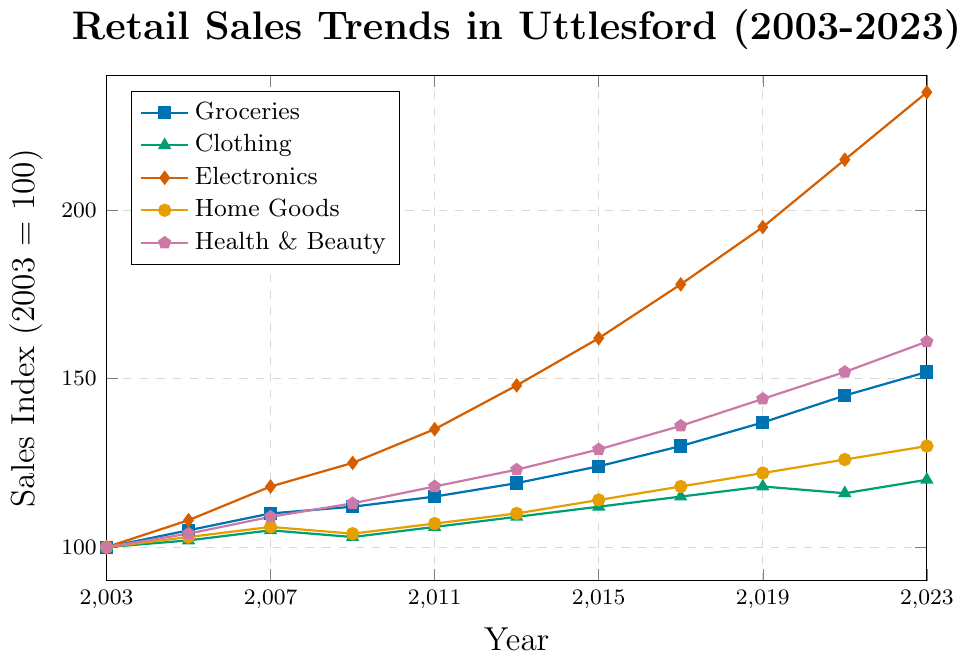What is the trend for Electronics sales from 2003 to 2023? By observing the line representing Electronics, which is marked by diamonds and colored red, it starts at 100 in 2003 and consistently increases, reaching 235 in 2023.
Answer: Increasing Which product category showed the highest sales increase over the 20 years? By comparing the ending values of each product category in 2023, Electronics showed the highest increase from 100 in 2003 to 235 in 2023.
Answer: Electronics How did Clothing sales change from 2019 to 2021? By observing the green line with triangles for Clothing, it slightly decreased from 118 in 2019 to 116 in 2021.
Answer: Decreased What was the average sales index of Groceries in the years 2011, 2015, and 2019? The value for Groceries in 2011 is 115, in 2015 is 124, and in 2019 is 137. Adding these values results in 115 + 124 + 137 = 376, and the average is 376 / 3 = 125.33.
Answer: 125.33 Compare Home Goods and Health & Beauty sales in 2023. Which was higher and by how much? The value for Home Goods in 2023 is 130, and for Health & Beauty, it is 161. The difference is 161 - 130 = 31.
Answer: Health & Beauty by 31 Which product category had the most stable sales trend over the 20 years, with the least fluctuations? By examining the slopes of the trends, Clothing (green line with triangles) shows the most stable trend with fewer fluctuations and a slower increase compared to other categories.
Answer: Clothing In which year did Electronics surpass 150 in sales index? By observing the red line with diamonds, Electronics surpassed a sales index of 150 between 2013 and 2015. In 2015, its value was 162.
Answer: 2015 What was the total sales index of all categories combined in 2009? Summing up the sales indices for all categories in 2009: Groceries (112) + Clothing (103) + Electronics (125) + Home Goods (104) + Health & Beauty (113) = 112 + 103 + 125 + 104 + 113 = 557.
Answer: 557 What is the visual difference between the trends for Health & Beauty and Home Goods from 2003 to 2023? The purple line with pentagons (Health & Beauty) consistently rises at a faster rate than the orange line with circles (Home Goods), indicating more substantial growth in sales for Health & Beauty compared to the steadier and slower rise of Home Goods.
Answer: Health & Beauty rises faster 